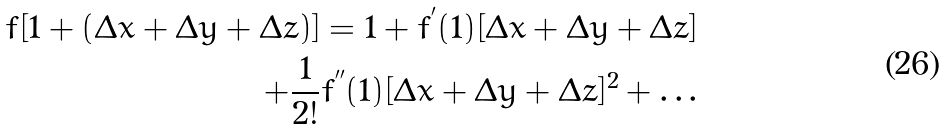<formula> <loc_0><loc_0><loc_500><loc_500>f [ 1 + ( \Delta x + \Delta y + \Delta z ) ] = 1 + f ^ { ^ { \prime } } ( 1 ) [ \Delta x + \Delta y + \Delta z ] \\ + \frac { 1 } { 2 ! } f ^ { ^ { \prime \prime } } ( 1 ) [ \Delta x + \Delta y + \Delta z ] ^ { 2 } + \dots</formula> 